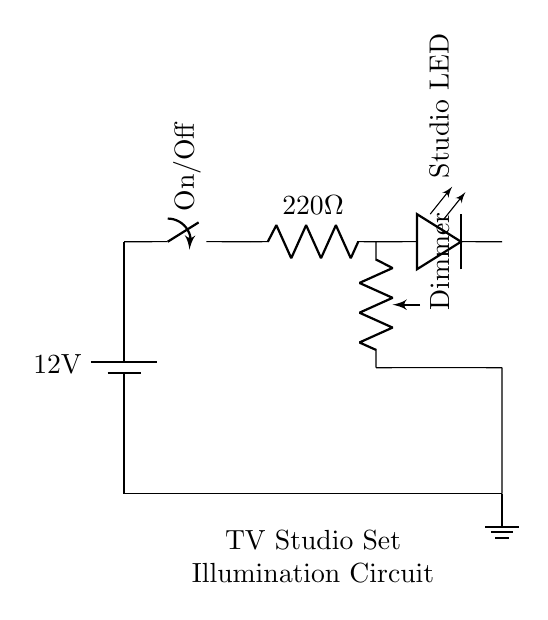What is the voltage of the power supply? The power supply is marked as 12 volts in the circuit, which indicates the voltage source powering the circuit.
Answer: 12 volts What is the value of the current limiting resistor? The current limiting resistor is labeled as 220 Ohms in the circuit diagram, which is necessary to limit the current flowing through the LED.
Answer: 220 Ohms What type of component is used for dimming? The dimming function in the circuit is provided by a potentiometer, which is denoted as "Dimmer" and used to adjust light intensity.
Answer: Potentiometer Which component acts as the switch in the circuit? The switch component in the diagram is represented as an "On/Off" switch, allowing the user to control the flow of electrical current to the LED.
Answer: Switch How many LEDs are present in the circuit? In the circuit diagram, there is only one LED component labeled as "Studio LED," which is the illumination source.
Answer: One What type of circuit is this considered? This circuit can be classified as a simple LED lighting control circuit specifically designed for studio set illumination, incorporating a power supply, switch, resistor, LED, and dimmer.
Answer: Simple LED lighting control circuit 